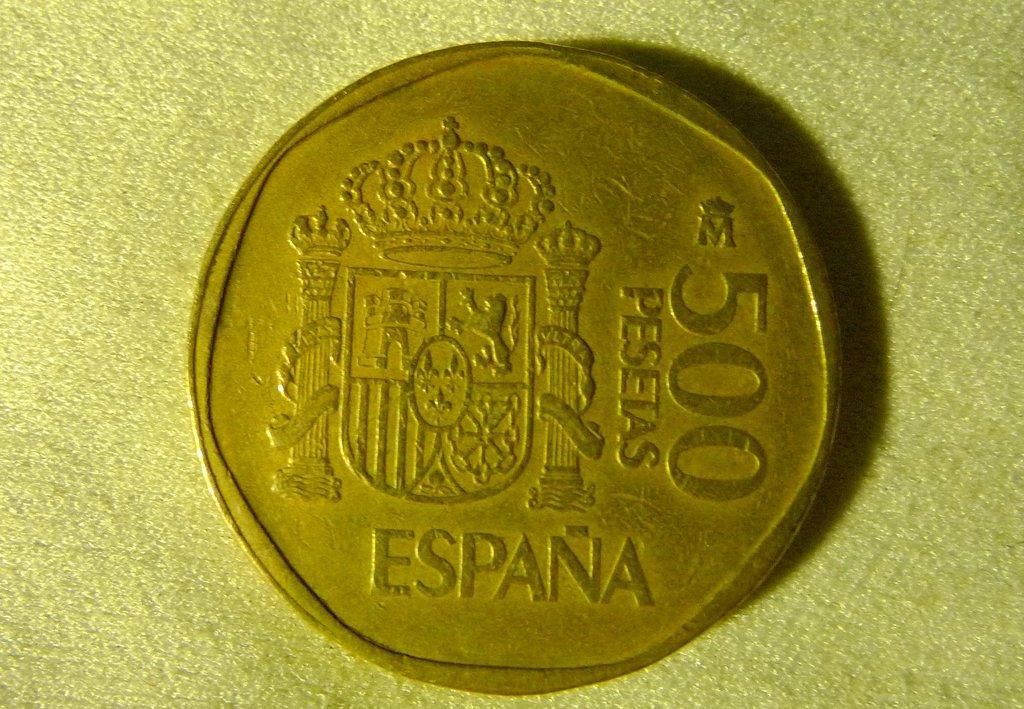Where does the coin come from?
Give a very brief answer. Espana. What number is on the right side of the coin?
Offer a terse response. 500. 